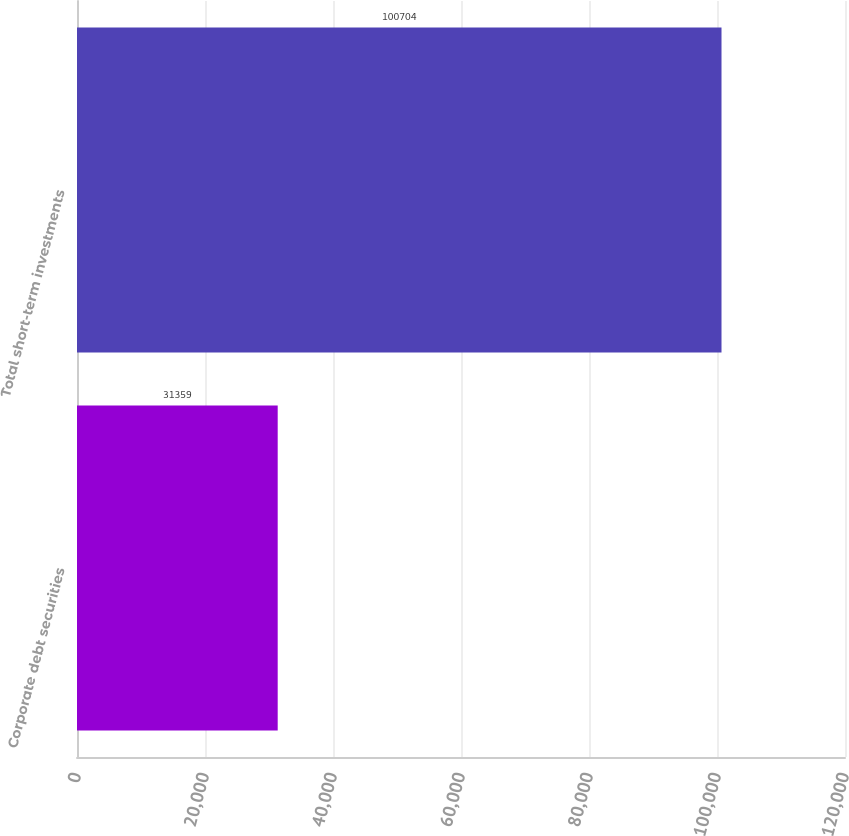Convert chart to OTSL. <chart><loc_0><loc_0><loc_500><loc_500><bar_chart><fcel>Corporate debt securities<fcel>Total short-term investments<nl><fcel>31359<fcel>100704<nl></chart> 